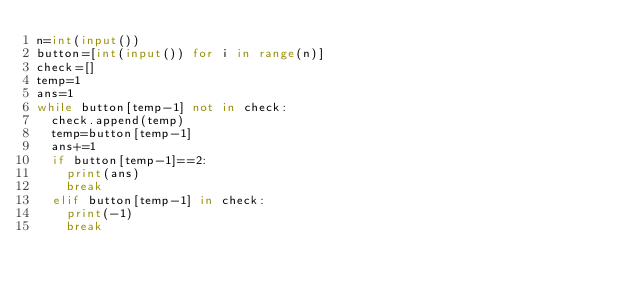Convert code to text. <code><loc_0><loc_0><loc_500><loc_500><_Python_>n=int(input())
button=[int(input()) for i in range(n)]
check=[]
temp=1
ans=1
while button[temp-1] not in check:
  check.append(temp)
  temp=button[temp-1]
  ans+=1
  if button[temp-1]==2:
    print(ans)
    break
  elif button[temp-1] in check:
    print(-1)
    break
</code> 